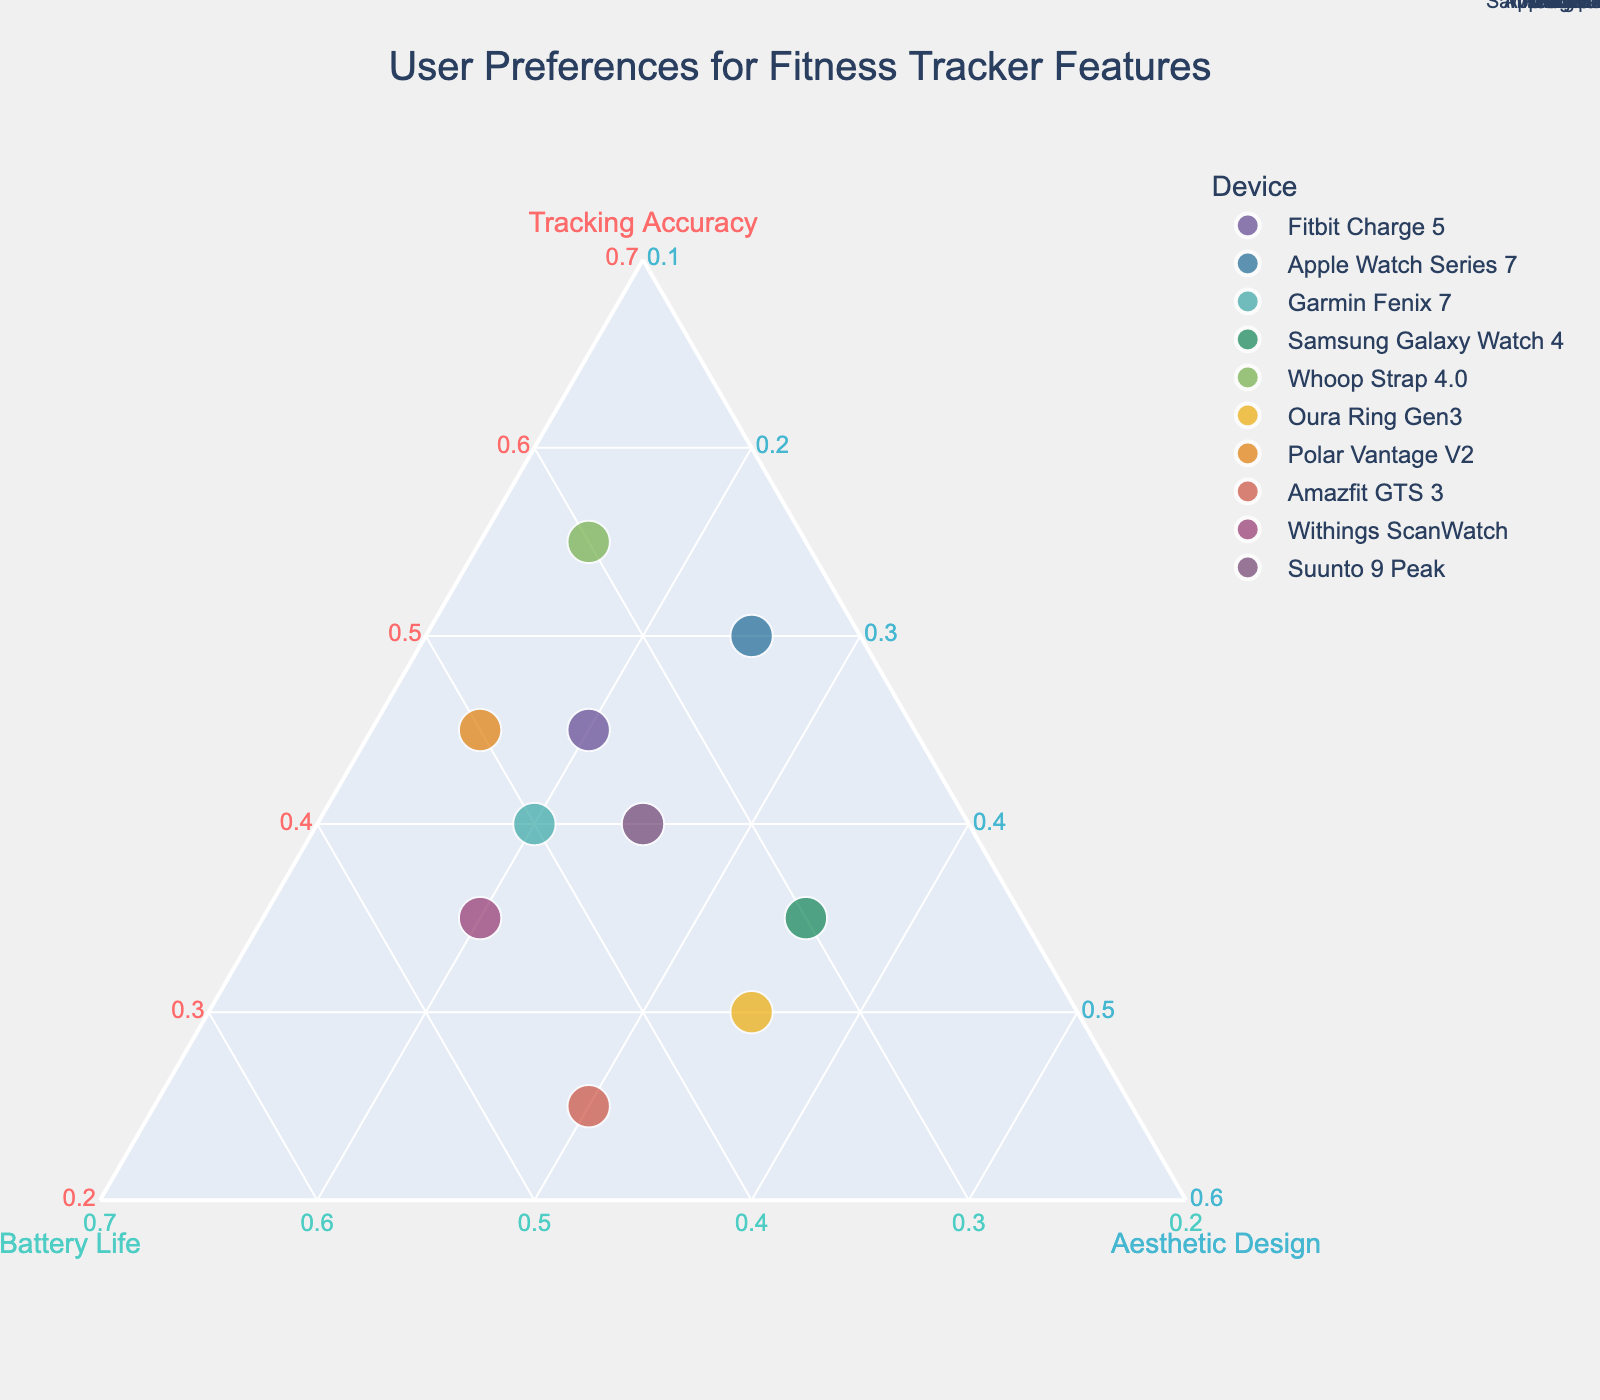Which device places the most emphasis on Tracking Accuracy? By looking at the ternary plot, identify which data point is closest to the Tracking Accuracy axis. 'Whoop Strap 4.0' is closest to the 'Tracking Accuracy' axis with a value of 55%.
Answer: Whoop Strap 4.0 What is the title of the chart? The title of the chart is displayed at the top of the ternary plot. It reads "User Preferences for Fitness Tracker Features".
Answer: User Preferences for Fitness Tracker Features How many devices place a higher emphasis on Battery Life compared to Aesthetic Design? To determine this, we look for data points where the percentage for Battery Life is greater than that for Aesthetic Design. These devices are Fitbit Charge 5, Apple Watch Series 7, Garmin Fenix 7, Whoop Strap 4.0, Polar Vantage V2, Amazfit GTS 3, and Withings ScanWatch.
Answer: 7 devices Which device is closest to having an equal emphasis on each feature? Look for the data point closest to the center of the ternary plot, where the values for Tracking Accuracy, Battery Life, and Aesthetic Design are nearly equal. 'Samsung Galaxy Watch 4' has values 35%, 30%, and 35%.
Answer: Samsung Galaxy Watch 4 What are the axes of the ternary plot labeled as? The labels are written along each axis of the ternary plot. They are 'Tracking Accuracy', 'Battery Life', and 'Aesthetic Design'.
Answer: Tracking Accuracy, Battery Life, Aesthetic Design Which two devices have the closest emphasis on Battery Life? Look at the Battery Life values and find the two closest data points. 'Amazfit GTS 3' and 'Withings ScanWatch' both have a Battery Life emphasis of 45%.
Answer: Amazfit GTS 3 and Withings ScanWatch Which device emphasizes Aesthetic Design the most? Identify the data point that is closest to the Aesthetic Design axis. 'Samsung Galaxy Watch 4' has the highest value for Aesthetic Design at 35%.
Answer: Samsung Galaxy Watch 4 What is the smallest value for Aesthetic Design among all the devices? Find the lowest value for Aesthetic Design in the data points. That is 15%, shared by 'Whoop Strap 4.0' and 'Polar Vantage V2'.
Answer: 15% Which device has a balance between Tracking Accuracy and Battery Life, with less emphasis on Aesthetic Design? Look for a point that is almost equidistant from the Tracking Accuracy and Battery Life axes but relatively far from the Aesthetic Design axis. 'Polar Vantage V2' has 45% Tracking Accuracy, 40% Battery Life, and 15% Aesthetic Design.
Answer: Polar Vantage V2 